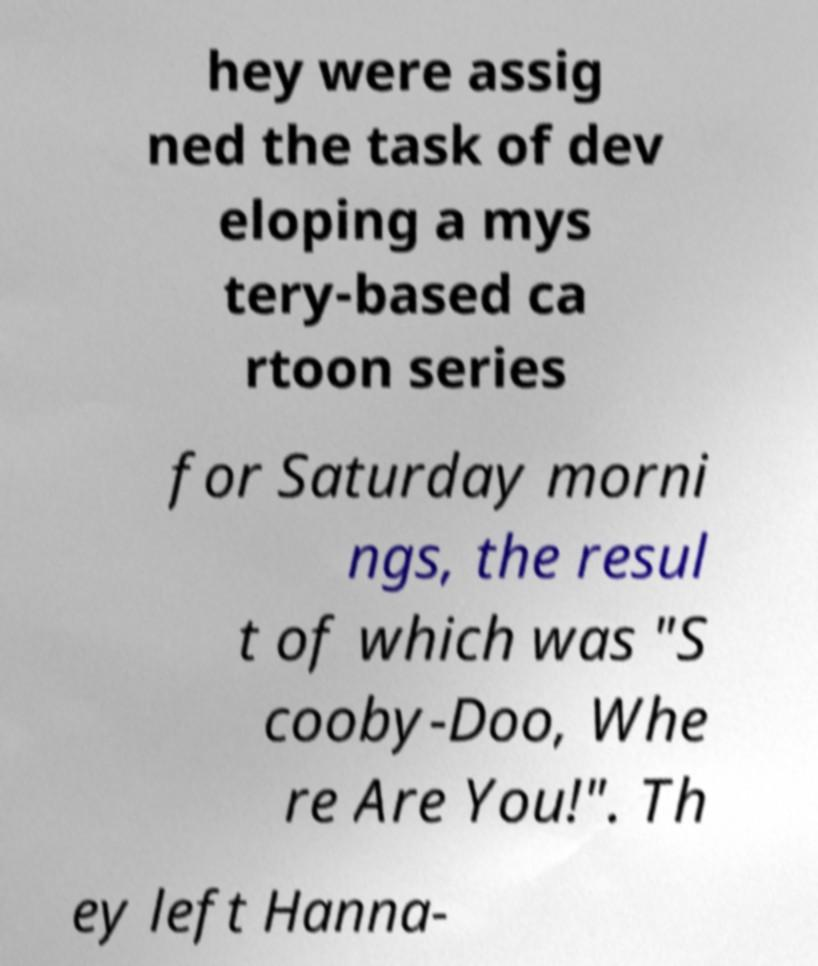I need the written content from this picture converted into text. Can you do that? hey were assig ned the task of dev eloping a mys tery-based ca rtoon series for Saturday morni ngs, the resul t of which was "S cooby-Doo, Whe re Are You!". Th ey left Hanna- 